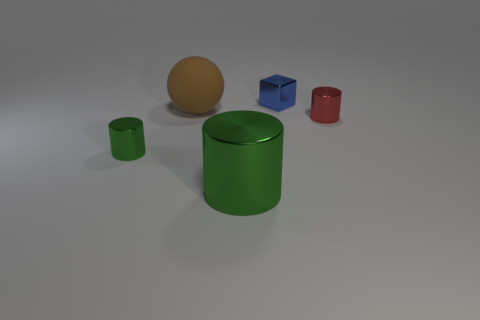Suppose the red cylinder was made of glass, how would that change its appearance in this setting? If the red cylinder were glass, it would transmit and refract the light, creating distortion and magnification effects on the objects behind it. Its edges would catch highlights and the shadow it casts would be softer due to light passing through. 